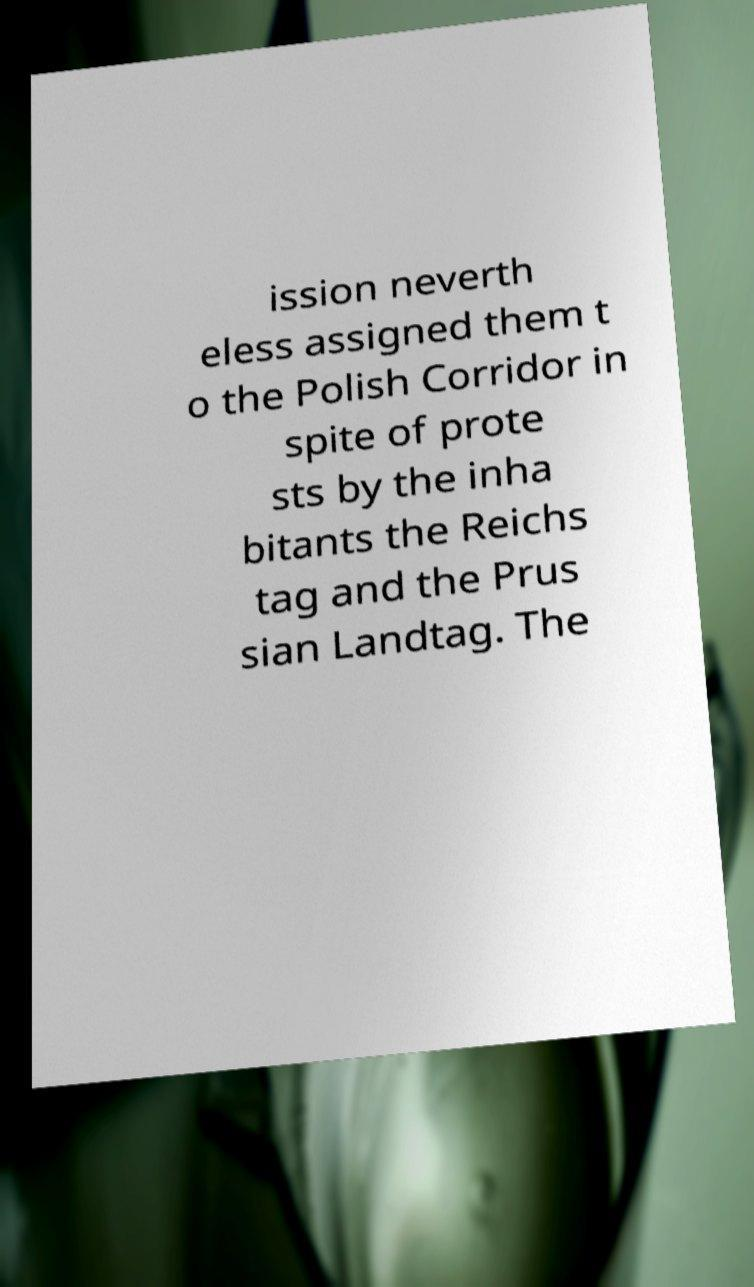What messages or text are displayed in this image? I need them in a readable, typed format. ission neverth eless assigned them t o the Polish Corridor in spite of prote sts by the inha bitants the Reichs tag and the Prus sian Landtag. The 